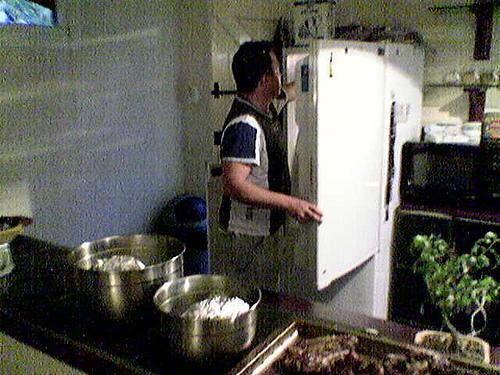What is the man touching? Please explain your reasoning. refrigerator door. The appliance is opened by this method.  it is in the kitchen which is typically where this appliance is found and it is opened in this type of way. 